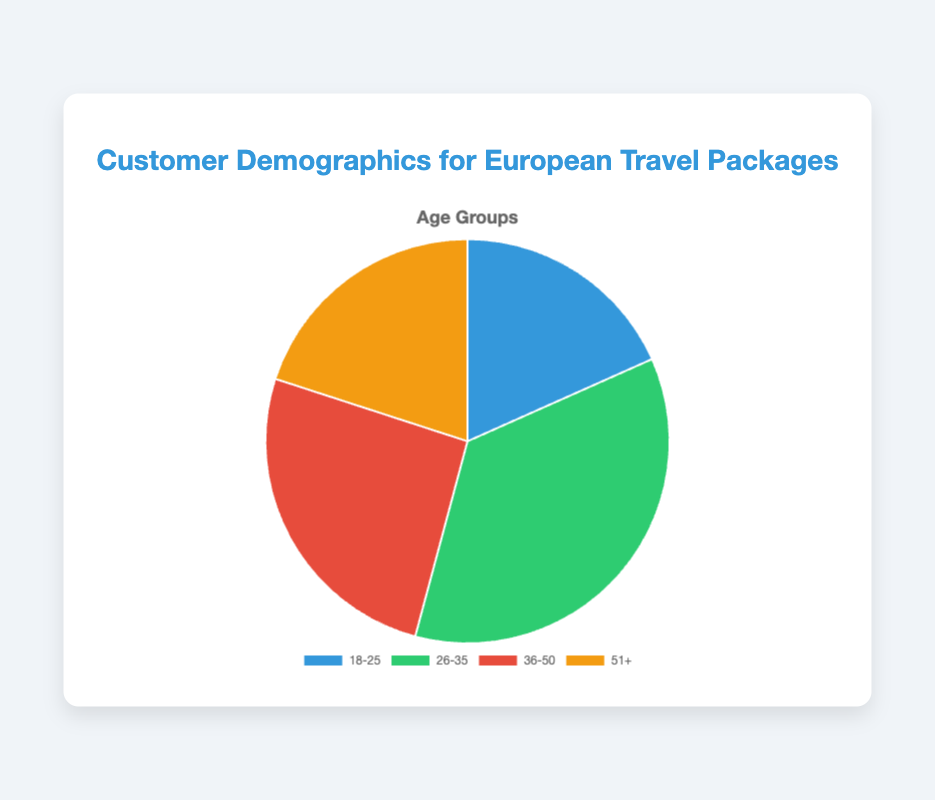What percentage of customers fall into the 26-35 age group? The total number of customers is the sum of all age groups: 2200 + 4300 + 3100 + 2400 = 12000. The number of customers in the 26-35 age group is 4300. So the percentage is (4300 / 12000) * 100 = 35.83%
Answer: 35.83% Which age group has the fewest customers? By comparing the values, we see that the 18-25 age group has 2200 customers, 26-35 has 4300, 36-50 has 3100, and 51+ has 2400. The smallest value among these is 2200 from the 18-25 age group.
Answer: 18-25 What is the sum of customers aged 18-25 and 51+? The number of customers in the 18-25 age group is 2200, and in the 51+ age group is 2400. The sum is 2200 + 2400 = 4600
Answer: 4600 Which age group occupies the largest segment in the pie chart? By observing the data points, the 26-35 age group has the highest number with 4300 customers, meaning it occupies the largest segment.
Answer: 26-35 How many more customers are there in the 36-50 age group compared to the 51+ age group? The number of customers in the 36-50 age group is 3100, and in the 51+ age group is 2400. The difference is 3100 - 2400 = 700
Answer: 700 What is the average number of customers across all age groups? To find the average, we sum the number of customers in all age groups and divide by the number of age groups. The sum is 2200 + 4300 + 3100 + 2400 = 12000. There are 4 age groups, so the average is 12000 / 4 = 3000
Answer: 3000 Between which two age groups is the difference in customer count the smallest? Calculating the differences: 26-35 and 36-50: 4300 - 3100 = 1200; 36-50 and 51+: 3100 - 2400 = 700; 51+ and 18-25: 2400 - 2200 = 200; The smallest difference is 200 between 51+ and 18-25.
Answer: 51+ and 18-25 Arrange the age groups in descending order based on the number of customers. The number of customers in descending order is: 26-35 (4300), 36-50 (3100), 51+ (2400), 18-25 (2200).
Answer: 26-35, 36-50, 51+, 18-25 What color represents the age group with the second highest number of customers? Based on the data, the second highest number of customers is in the 36-50 age group with 3100 customers. From the chart, the 36-50 age group is represented by the color red.
Answer: Red 